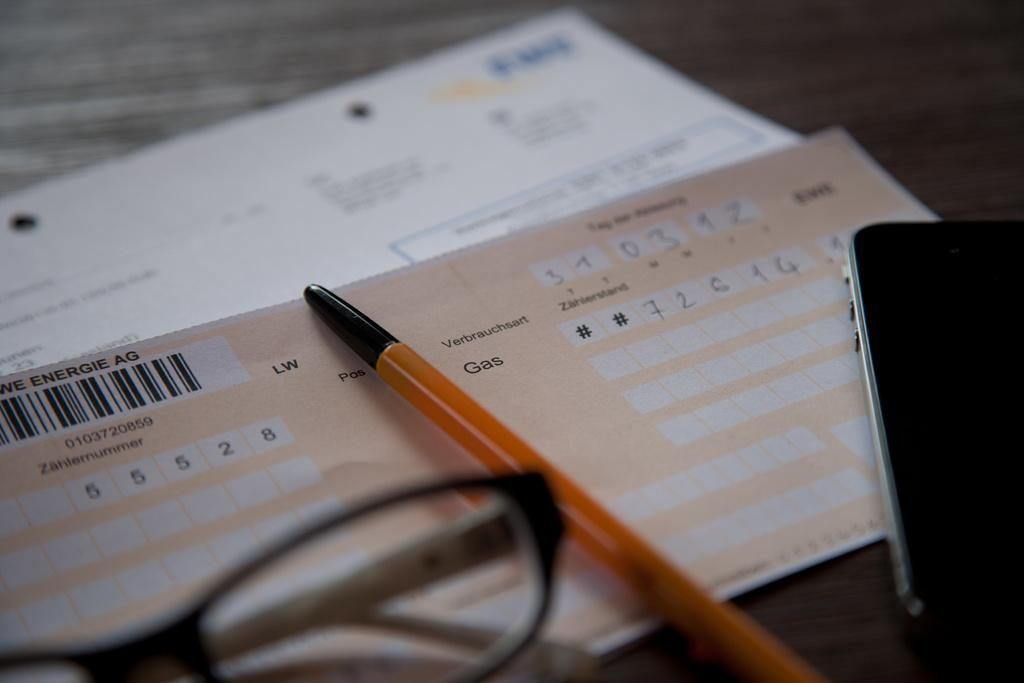<image>
Present a compact description of the photo's key features. the number 6 is on the piece of paper with a pen 